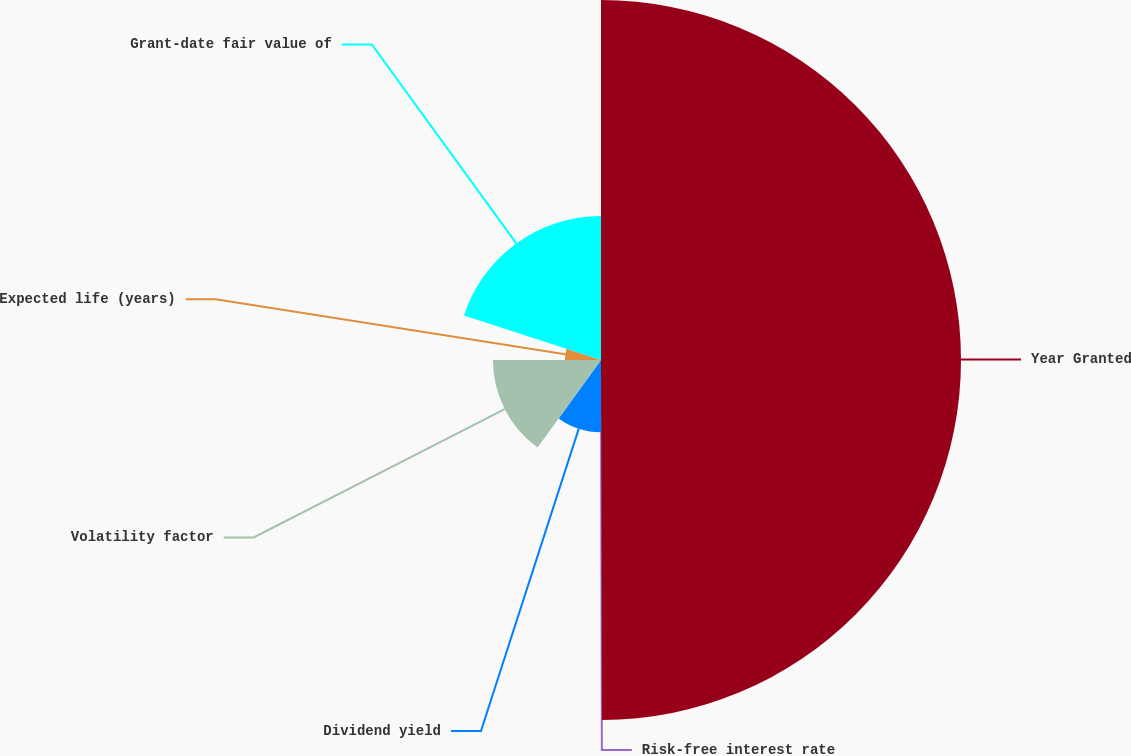Convert chart to OTSL. <chart><loc_0><loc_0><loc_500><loc_500><pie_chart><fcel>Year Granted<fcel>Risk-free interest rate<fcel>Dividend yield<fcel>Volatility factor<fcel>Expected life (years)<fcel>Grant-date fair value of<nl><fcel>49.96%<fcel>0.02%<fcel>10.01%<fcel>15.0%<fcel>5.02%<fcel>20.0%<nl></chart> 